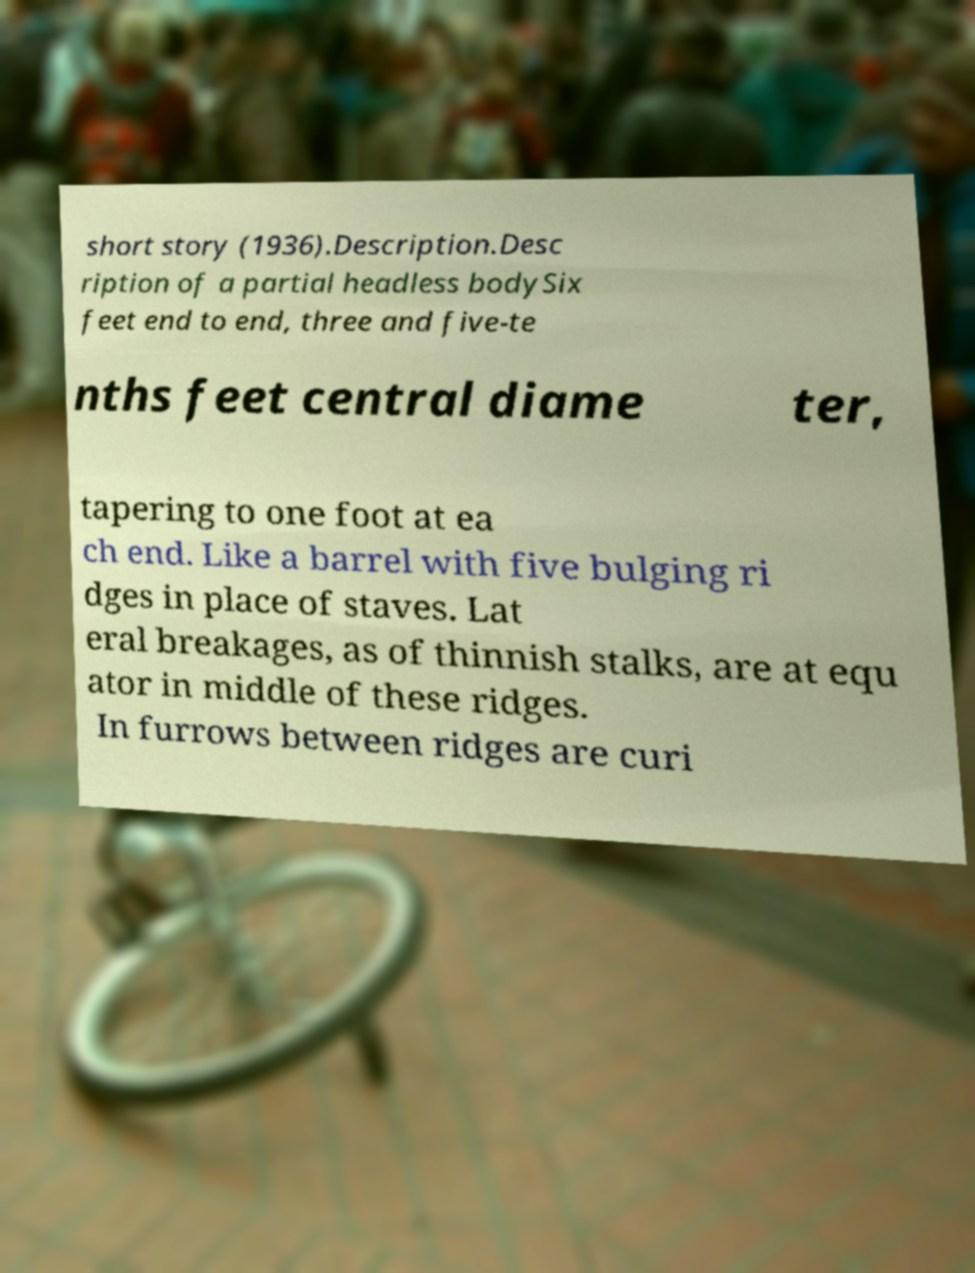What messages or text are displayed in this image? I need them in a readable, typed format. short story (1936).Description.Desc ription of a partial headless bodySix feet end to end, three and five-te nths feet central diame ter, tapering to one foot at ea ch end. Like a barrel with five bulging ri dges in place of staves. Lat eral breakages, as of thinnish stalks, are at equ ator in middle of these ridges. In furrows between ridges are curi 